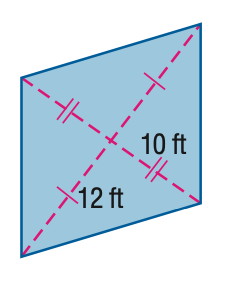Answer the mathemtical geometry problem and directly provide the correct option letter.
Question: Find the area of the kite.
Choices: A: 120 B: 180 C: 240 D: 300 C 